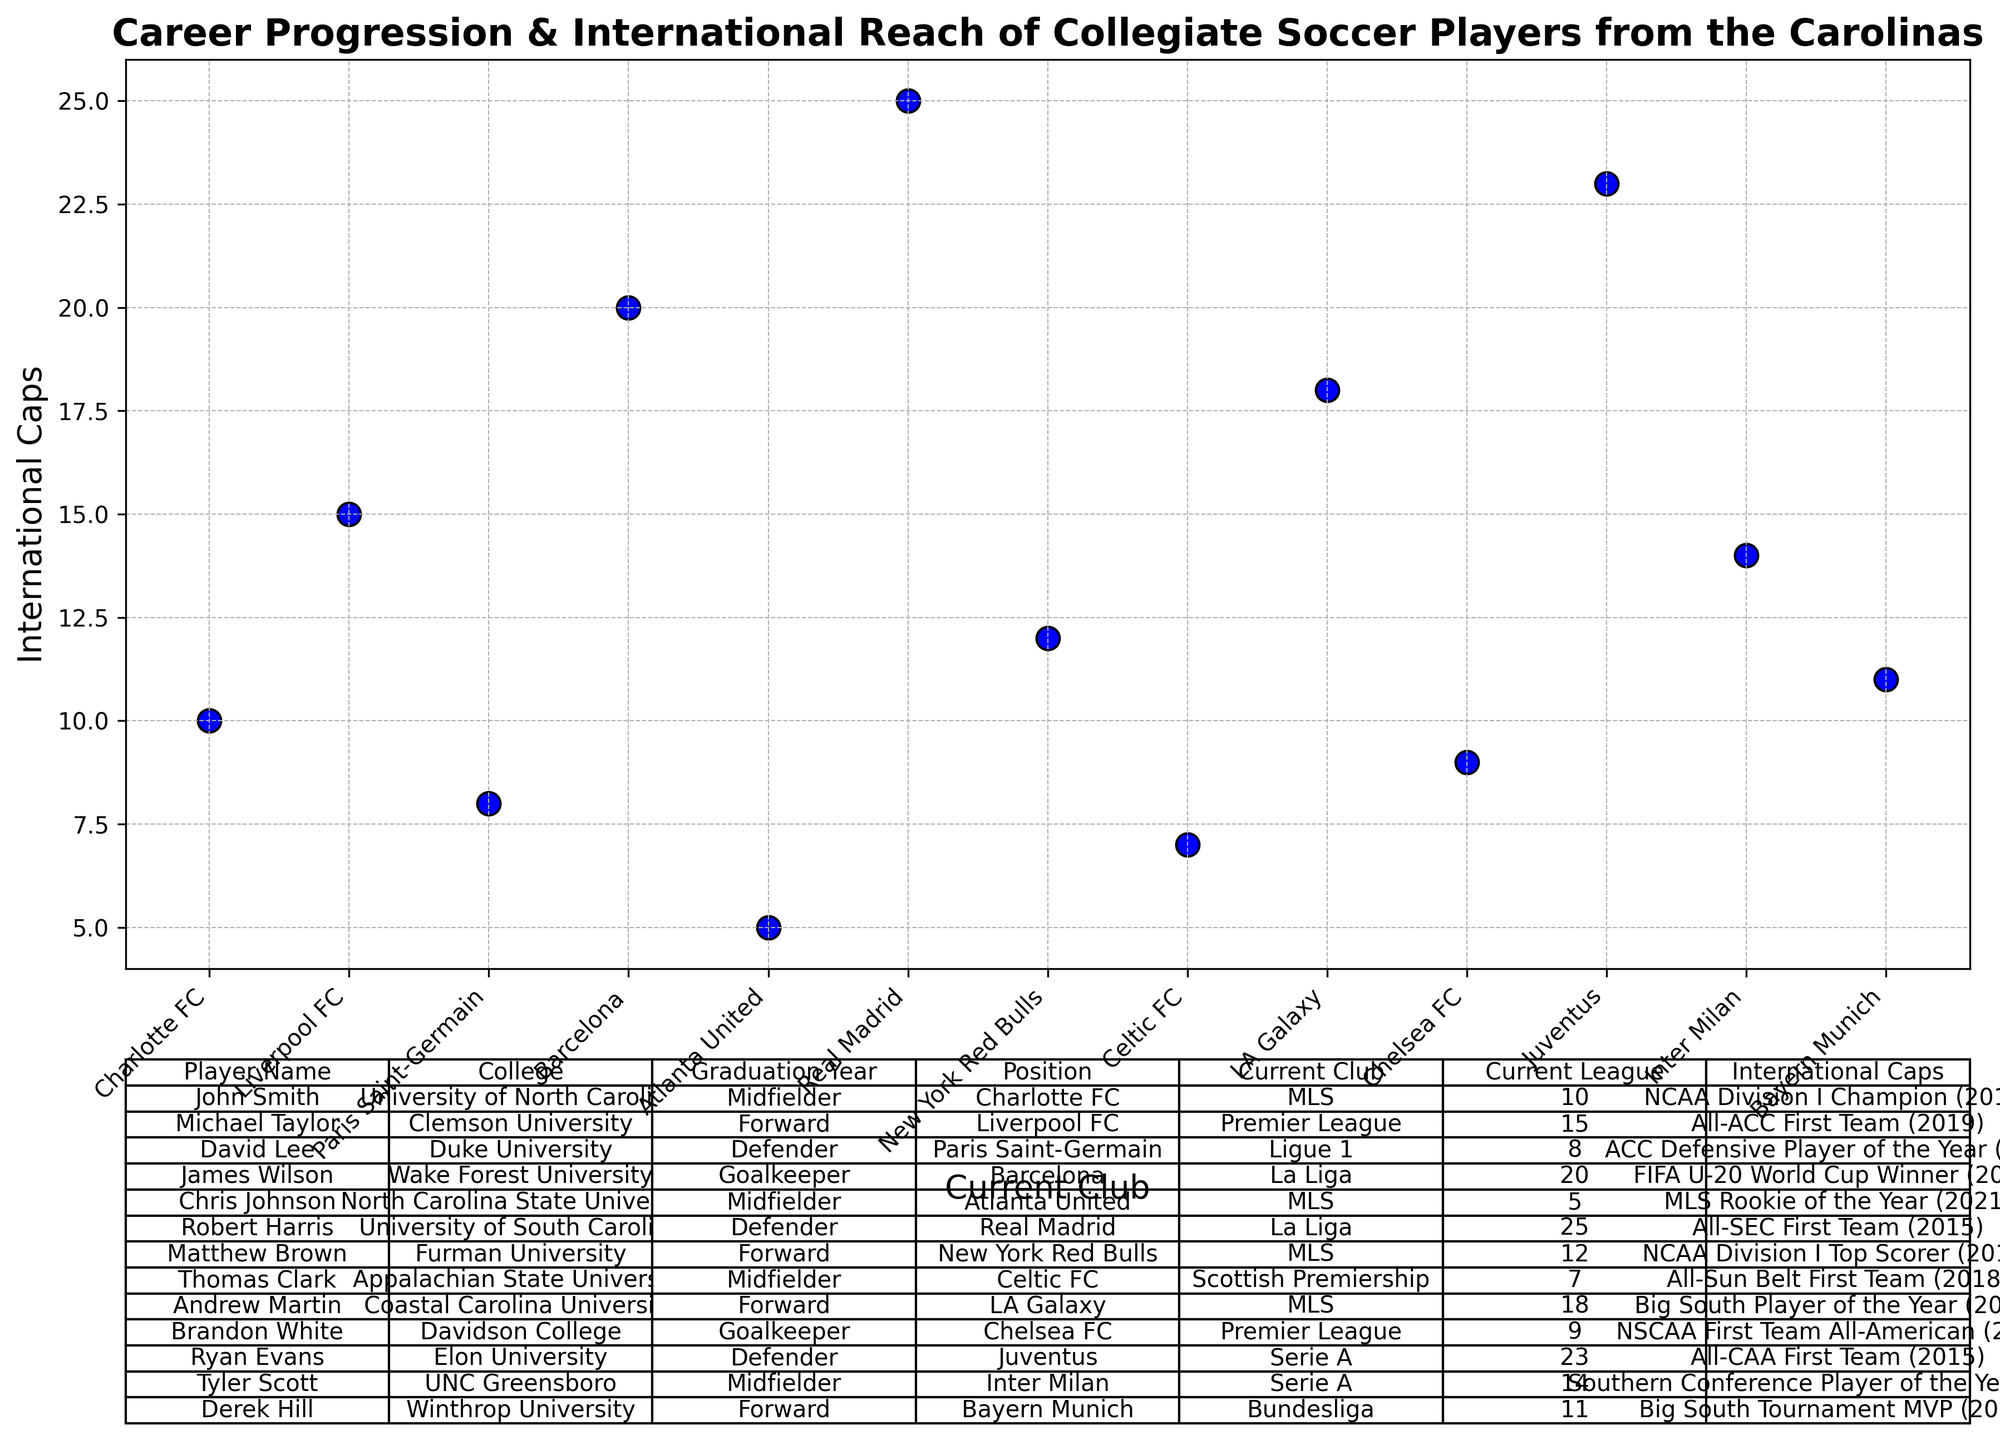What is the total number of international caps for players currently in La Liga? To find the total number of international caps for players in La Liga, first identify the players in La Liga from the table (James Wilson and Robert Harris). Then, sum their international caps (20 and 25).
Answer: 45 Which player has the highest number of international caps? To find the player with the highest number of international caps, scan through the "International Caps" column and identify the maximum value. Robert Harris with 25 caps has the highest.
Answer: Robert Harris How many players from the Carolinas are currently playing in the MLS? From the table, identify all players with "Current League" as MLS. There are five such players: John Smith, Chris Johnson, Matthew Brown, Andrew Martin, and Thomas Clark.
Answer: 5 Who has fewer international caps: Derek Hill or Tyler Scott? Check the "International Caps" for Derek Hill (11) and Tyler Scott (14). Derek Hill has fewer caps than Tyler Scott.
Answer: Derek Hill What is the average number of international caps for players who graduated in 2017? Identify players who graduated in 2017 (David Lee and Andrew Martin) and then calculate the average number of caps (8 and 18). The formula is (8 + 18) / 2.
Answer: 13 Which current club has the most players from this list? Identify and count the number of players in each "Current Club." The club appearing most frequently is identified by counting. Charlotte FC and Real Madrid each have one player from this list.
Answer: Charlotte FC and Real Madrid Which player graduated from Clemson University and how many international caps does he have? Identify the player from Clemson University (Michael Taylor) and check his "International Caps" (15).
Answer: Michael Taylor, 15 Compare the number of international caps between players in the Premier League and Bundesliga. Which league has more? Identify players in the Premier League (Michael Taylor and Brandon White, with 15 and 9 caps respectively) and Bundesliga (Derek Hill with 11 caps). Sum international caps for both leagues (15 + 9 = 24 for Premier League, 11 for Bundesliga). The Premier League has more.
Answer: Premier League List all goalkeepers and their current clubs. Locate players with the position "Goalkeeper." They are James Wilson and Brandon White. Their current clubs are Barcelona and Chelsea FC, respectively.
Answer: James Wilson (Barcelona), Brandon White (Chelsea FC) Which player received the Big South Player of the Year award and what is their current club? Identify the player with the "Major Achievements" as Big South Player of the Year (Andrew Martin) and their current club (LA Galaxy).
Answer: Andrew Martin, LA Galaxy 